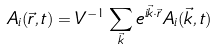Convert formula to latex. <formula><loc_0><loc_0><loc_500><loc_500>A _ { i } ( \vec { r } , t ) = V ^ { - 1 } \sum _ { \vec { k } } e ^ { i \vec { k } \cdot \vec { r } } A _ { i } ( \vec { k } , t )</formula> 